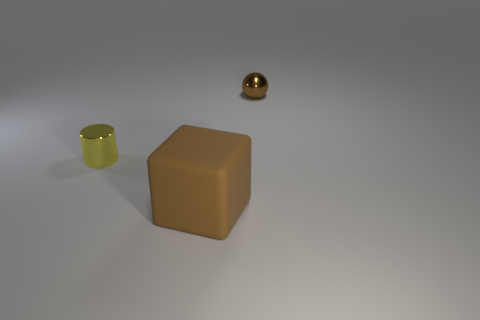Add 2 cyan metallic cylinders. How many objects exist? 5 Subtract all blocks. How many objects are left? 2 Add 1 large cubes. How many large cubes are left? 2 Add 1 large red metal cylinders. How many large red metal cylinders exist? 1 Subtract 0 green cubes. How many objects are left? 3 Subtract all small purple shiny spheres. Subtract all yellow metal things. How many objects are left? 2 